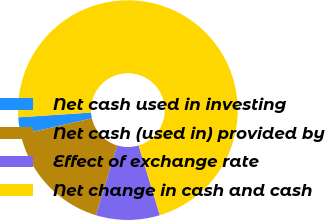<chart> <loc_0><loc_0><loc_500><loc_500><pie_chart><fcel>Net cash used in investing<fcel>Net cash (used in) provided by<fcel>Effect of exchange rate<fcel>Net change in cash and cash<nl><fcel>2.53%<fcel>16.72%<fcel>9.41%<fcel>71.33%<nl></chart> 